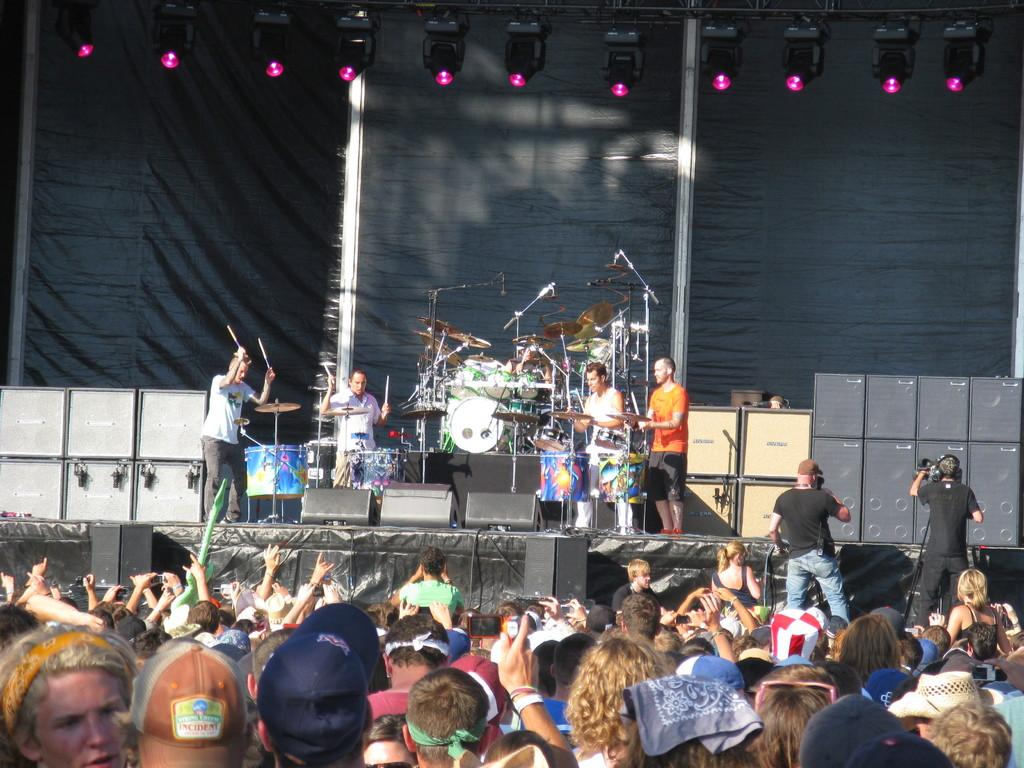How many people are in the image? There are people in the image, but the exact number is not specified. What are some of the people doing in the image? Some of the people are playing musical instruments. What can be seen in the background of the image? There are lights and speakers in the background of the image. Can you tell me how many plants are growing out of the hole in the image? There is no hole or plants present in the image. What type of amusement park ride can be seen in the background of the image? There is no amusement park ride present in the image; it features people playing musical instruments and background elements like lights and speakers. 